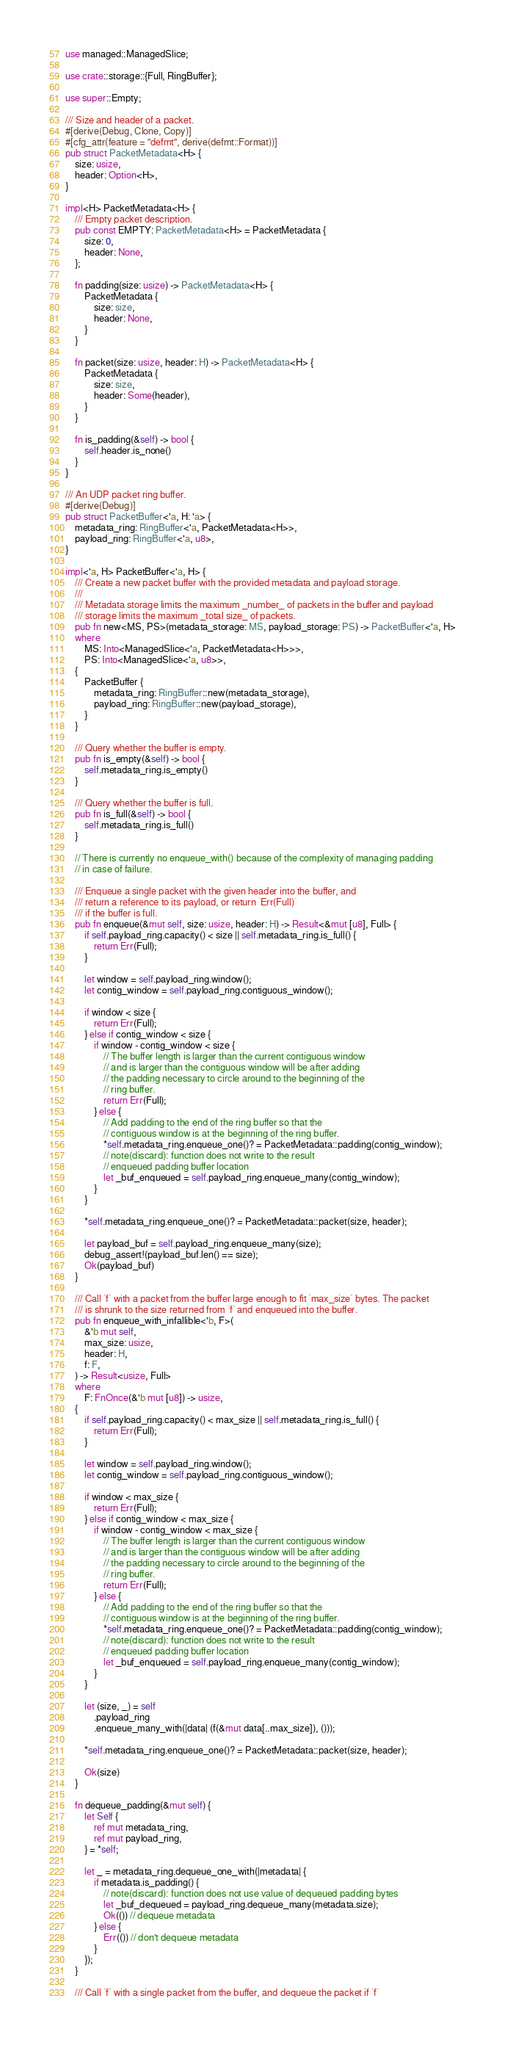<code> <loc_0><loc_0><loc_500><loc_500><_Rust_>use managed::ManagedSlice;

use crate::storage::{Full, RingBuffer};

use super::Empty;

/// Size and header of a packet.
#[derive(Debug, Clone, Copy)]
#[cfg_attr(feature = "defmt", derive(defmt::Format))]
pub struct PacketMetadata<H> {
    size: usize,
    header: Option<H>,
}

impl<H> PacketMetadata<H> {
    /// Empty packet description.
    pub const EMPTY: PacketMetadata<H> = PacketMetadata {
        size: 0,
        header: None,
    };

    fn padding(size: usize) -> PacketMetadata<H> {
        PacketMetadata {
            size: size,
            header: None,
        }
    }

    fn packet(size: usize, header: H) -> PacketMetadata<H> {
        PacketMetadata {
            size: size,
            header: Some(header),
        }
    }

    fn is_padding(&self) -> bool {
        self.header.is_none()
    }
}

/// An UDP packet ring buffer.
#[derive(Debug)]
pub struct PacketBuffer<'a, H: 'a> {
    metadata_ring: RingBuffer<'a, PacketMetadata<H>>,
    payload_ring: RingBuffer<'a, u8>,
}

impl<'a, H> PacketBuffer<'a, H> {
    /// Create a new packet buffer with the provided metadata and payload storage.
    ///
    /// Metadata storage limits the maximum _number_ of packets in the buffer and payload
    /// storage limits the maximum _total size_ of packets.
    pub fn new<MS, PS>(metadata_storage: MS, payload_storage: PS) -> PacketBuffer<'a, H>
    where
        MS: Into<ManagedSlice<'a, PacketMetadata<H>>>,
        PS: Into<ManagedSlice<'a, u8>>,
    {
        PacketBuffer {
            metadata_ring: RingBuffer::new(metadata_storage),
            payload_ring: RingBuffer::new(payload_storage),
        }
    }

    /// Query whether the buffer is empty.
    pub fn is_empty(&self) -> bool {
        self.metadata_ring.is_empty()
    }

    /// Query whether the buffer is full.
    pub fn is_full(&self) -> bool {
        self.metadata_ring.is_full()
    }

    // There is currently no enqueue_with() because of the complexity of managing padding
    // in case of failure.

    /// Enqueue a single packet with the given header into the buffer, and
    /// return a reference to its payload, or return `Err(Full)`
    /// if the buffer is full.
    pub fn enqueue(&mut self, size: usize, header: H) -> Result<&mut [u8], Full> {
        if self.payload_ring.capacity() < size || self.metadata_ring.is_full() {
            return Err(Full);
        }

        let window = self.payload_ring.window();
        let contig_window = self.payload_ring.contiguous_window();

        if window < size {
            return Err(Full);
        } else if contig_window < size {
            if window - contig_window < size {
                // The buffer length is larger than the current contiguous window
                // and is larger than the contiguous window will be after adding
                // the padding necessary to circle around to the beginning of the
                // ring buffer.
                return Err(Full);
            } else {
                // Add padding to the end of the ring buffer so that the
                // contiguous window is at the beginning of the ring buffer.
                *self.metadata_ring.enqueue_one()? = PacketMetadata::padding(contig_window);
                // note(discard): function does not write to the result
                // enqueued padding buffer location
                let _buf_enqueued = self.payload_ring.enqueue_many(contig_window);
            }
        }

        *self.metadata_ring.enqueue_one()? = PacketMetadata::packet(size, header);

        let payload_buf = self.payload_ring.enqueue_many(size);
        debug_assert!(payload_buf.len() == size);
        Ok(payload_buf)
    }

    /// Call `f` with a packet from the buffer large enough to fit `max_size` bytes. The packet
    /// is shrunk to the size returned from `f` and enqueued into the buffer.
    pub fn enqueue_with_infallible<'b, F>(
        &'b mut self,
        max_size: usize,
        header: H,
        f: F,
    ) -> Result<usize, Full>
    where
        F: FnOnce(&'b mut [u8]) -> usize,
    {
        if self.payload_ring.capacity() < max_size || self.metadata_ring.is_full() {
            return Err(Full);
        }

        let window = self.payload_ring.window();
        let contig_window = self.payload_ring.contiguous_window();

        if window < max_size {
            return Err(Full);
        } else if contig_window < max_size {
            if window - contig_window < max_size {
                // The buffer length is larger than the current contiguous window
                // and is larger than the contiguous window will be after adding
                // the padding necessary to circle around to the beginning of the
                // ring buffer.
                return Err(Full);
            } else {
                // Add padding to the end of the ring buffer so that the
                // contiguous window is at the beginning of the ring buffer.
                *self.metadata_ring.enqueue_one()? = PacketMetadata::padding(contig_window);
                // note(discard): function does not write to the result
                // enqueued padding buffer location
                let _buf_enqueued = self.payload_ring.enqueue_many(contig_window);
            }
        }

        let (size, _) = self
            .payload_ring
            .enqueue_many_with(|data| (f(&mut data[..max_size]), ()));

        *self.metadata_ring.enqueue_one()? = PacketMetadata::packet(size, header);

        Ok(size)
    }

    fn dequeue_padding(&mut self) {
        let Self {
            ref mut metadata_ring,
            ref mut payload_ring,
        } = *self;

        let _ = metadata_ring.dequeue_one_with(|metadata| {
            if metadata.is_padding() {
                // note(discard): function does not use value of dequeued padding bytes
                let _buf_dequeued = payload_ring.dequeue_many(metadata.size);
                Ok(()) // dequeue metadata
            } else {
                Err(()) // don't dequeue metadata
            }
        });
    }

    /// Call `f` with a single packet from the buffer, and dequeue the packet if `f`</code> 